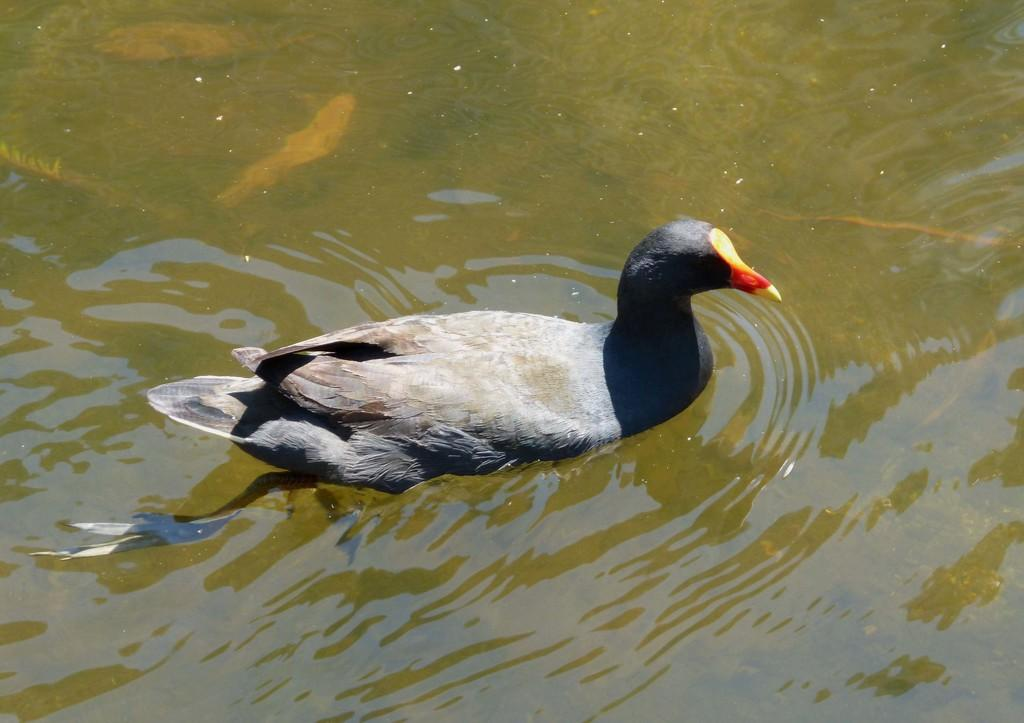What animal is present in the image? There is a duck in the image. Where is the duck located in relation to the water? The duck is partially in the water. What is the duck doing in the image? The duck is swimming. Can you see any kittens playing with ice in the image? No, there are no kittens or ice present in the image; it features a duck swimming in the water. 